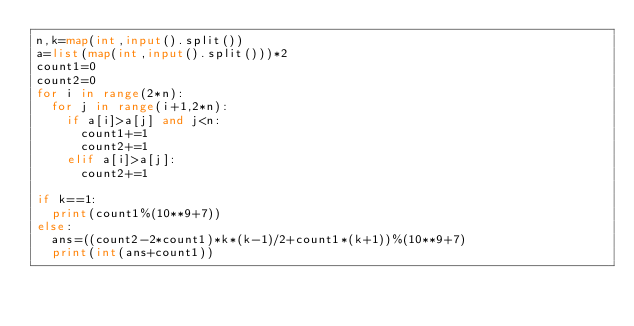<code> <loc_0><loc_0><loc_500><loc_500><_Python_>n,k=map(int,input().split())
a=list(map(int,input().split()))*2
count1=0
count2=0
for i in range(2*n):
  for j in range(i+1,2*n):
    if a[i]>a[j] and j<n:
      count1+=1
      count2+=1
    elif a[i]>a[j]:
      count2+=1

if k==1:
  print(count1%(10**9+7))
else:
  ans=((count2-2*count1)*k*(k-1)/2+count1*(k+1))%(10**9+7)
  print(int(ans+count1))  	</code> 